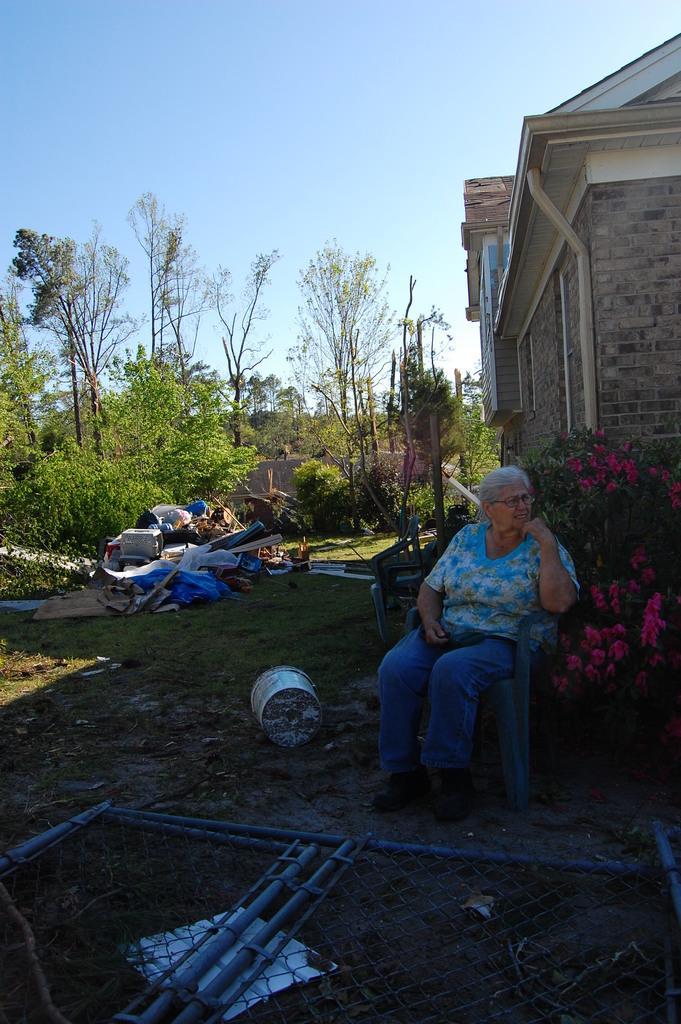Could you give a brief overview of what you see in this image? There is a woman sitting on chair, we can see bucket, mesh, rods and grass. We can see house, plants, flowers and chair. In the background we can see covers and few objects. We can see trees and sky. 